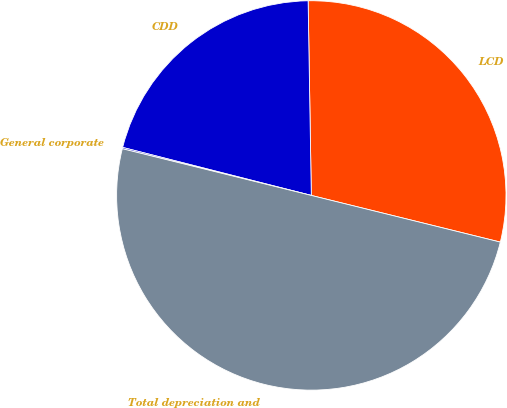Convert chart to OTSL. <chart><loc_0><loc_0><loc_500><loc_500><pie_chart><fcel>LCD<fcel>CDD<fcel>General corporate<fcel>Total depreciation and<nl><fcel>29.11%<fcel>20.77%<fcel>0.11%<fcel>50.0%<nl></chart> 